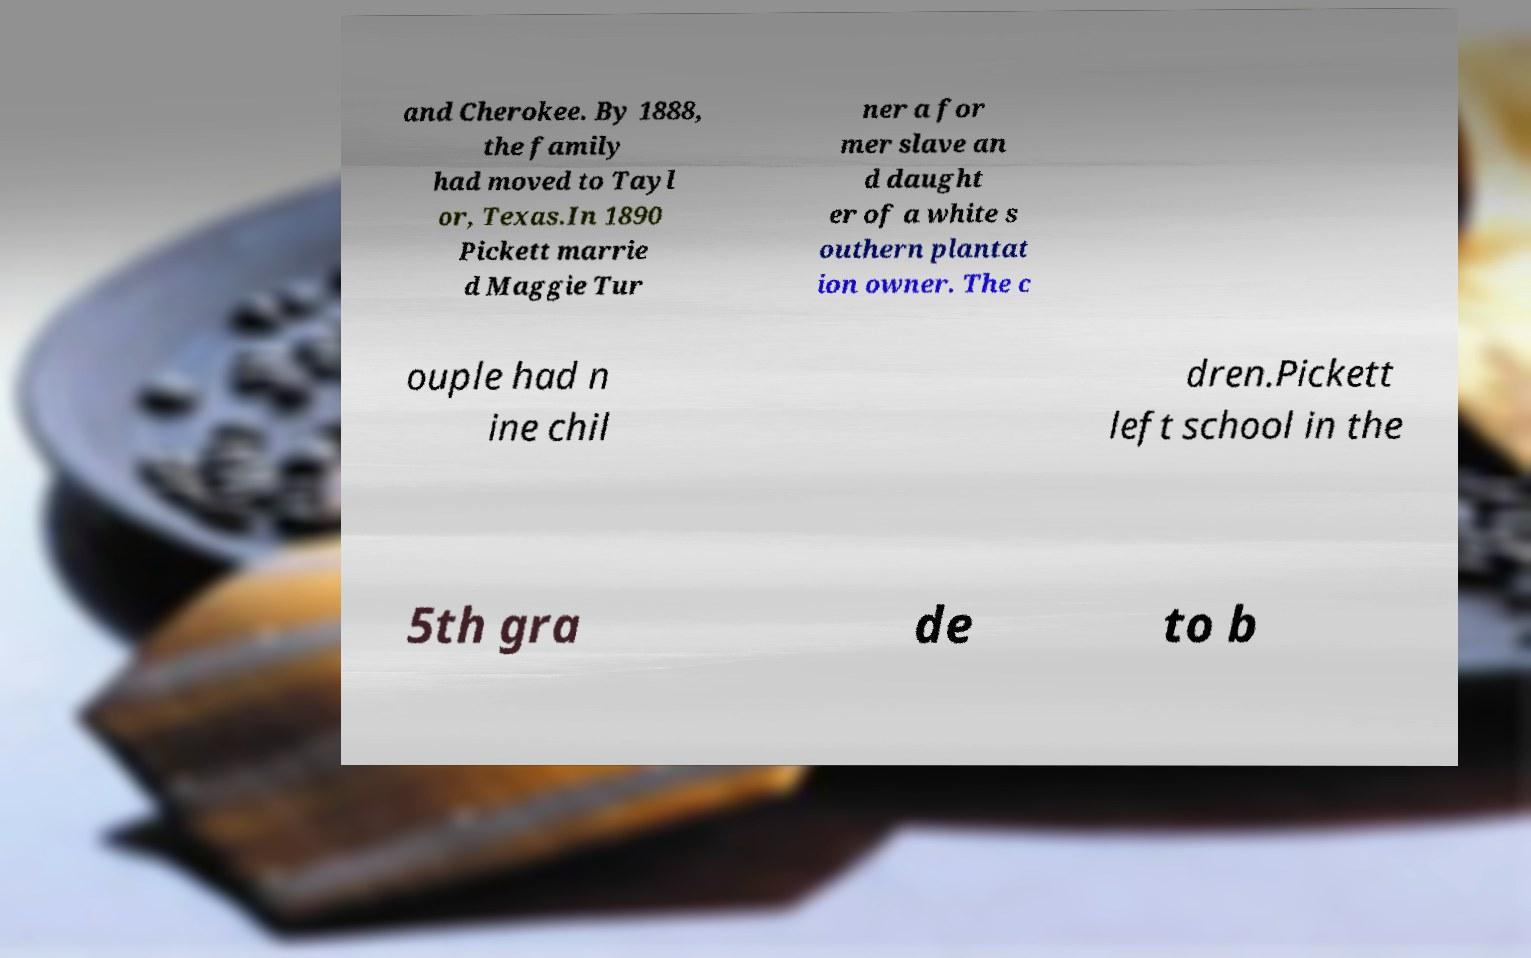Please identify and transcribe the text found in this image. and Cherokee. By 1888, the family had moved to Tayl or, Texas.In 1890 Pickett marrie d Maggie Tur ner a for mer slave an d daught er of a white s outhern plantat ion owner. The c ouple had n ine chil dren.Pickett left school in the 5th gra de to b 